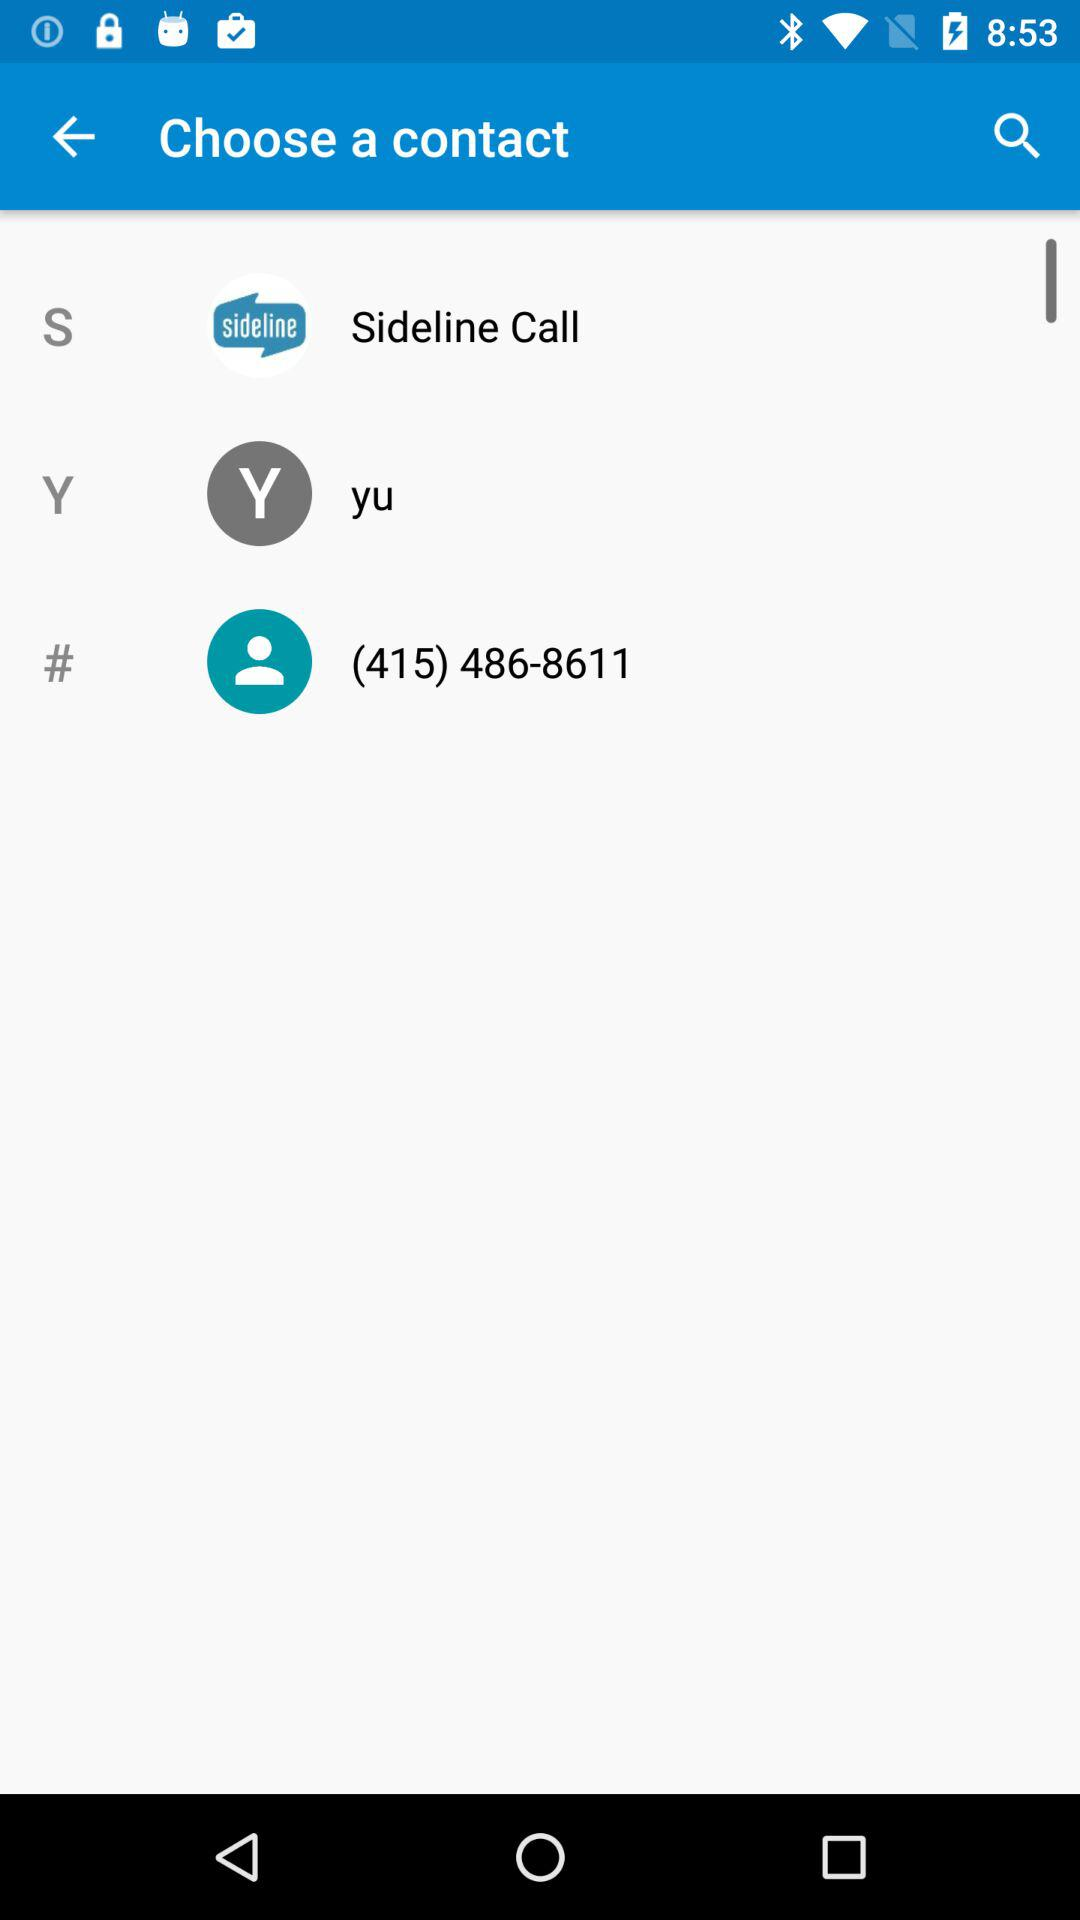What are the options for "Choose a contact"? The options are "Sideline Call", "yu" and (415) 486-8611. 